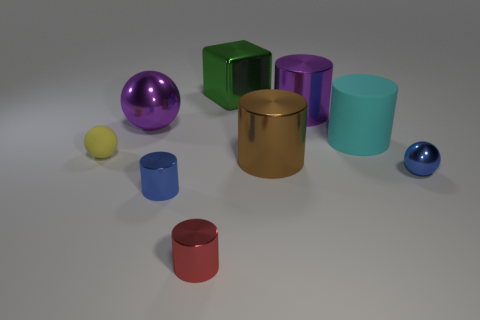Subtract 1 cylinders. How many cylinders are left? 4 Subtract all green cylinders. Subtract all green cubes. How many cylinders are left? 5 Add 1 tiny metallic objects. How many objects exist? 10 Subtract all spheres. How many objects are left? 6 Add 2 big rubber spheres. How many big rubber spheres exist? 2 Subtract 0 yellow blocks. How many objects are left? 9 Subtract all big green metal things. Subtract all blocks. How many objects are left? 7 Add 2 big purple metal things. How many big purple metal things are left? 4 